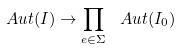<formula> <loc_0><loc_0><loc_500><loc_500>\ A u t ( I ) \to \prod _ { e \in \Sigma } \ A u t ( I _ { 0 } )</formula> 